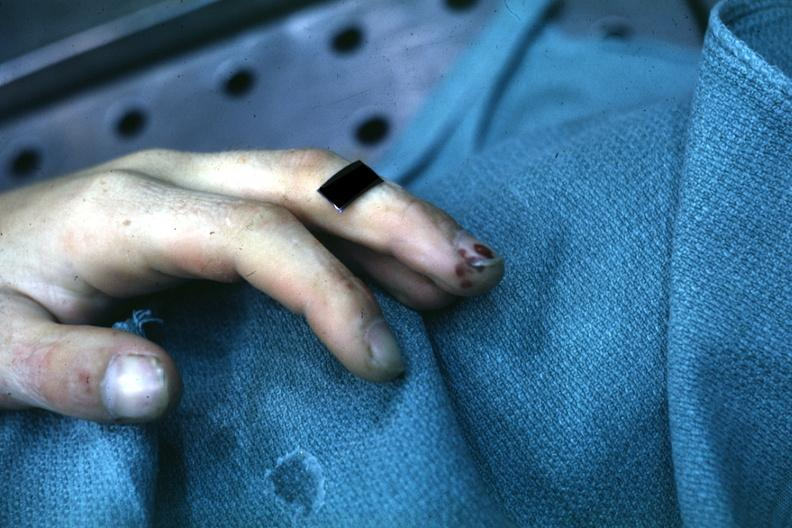s dysplastic present?
Answer the question using a single word or phrase. No 